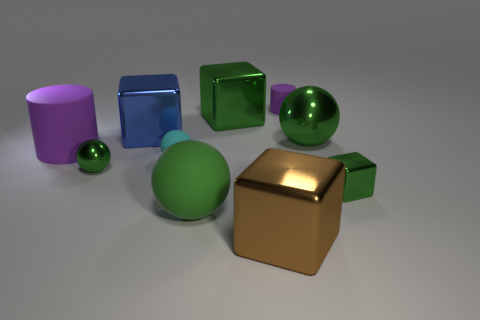Do the small purple cylinder right of the big blue metal thing and the cube to the left of the big green matte ball have the same material?
Your answer should be compact. No. Are there more tiny cyan spheres that are right of the small shiny sphere than big blue things that are in front of the big blue shiny object?
Offer a terse response. Yes. There is a brown thing that is the same size as the green rubber sphere; what shape is it?
Provide a succinct answer. Cube. What number of objects are small purple things or metallic objects to the right of the green matte object?
Your answer should be compact. 5. Does the big rubber cylinder have the same color as the large matte ball?
Your response must be concise. No. How many brown metallic things are to the right of the big green shiny ball?
Provide a short and direct response. 0. What color is the tiny ball that is the same material as the brown object?
Provide a short and direct response. Green. How many shiny objects are either small purple things or purple things?
Give a very brief answer. 0. Is the cyan ball made of the same material as the large purple cylinder?
Provide a short and direct response. Yes. What is the shape of the tiny rubber object to the right of the large brown shiny thing?
Make the answer very short. Cylinder. 